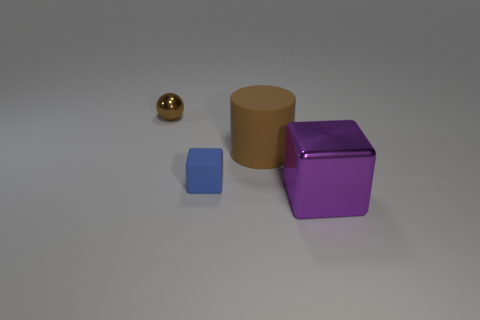Are there any spheres? Yes, there is a single golden sphere located to the left side of the arrangement of shapes present in the image. 